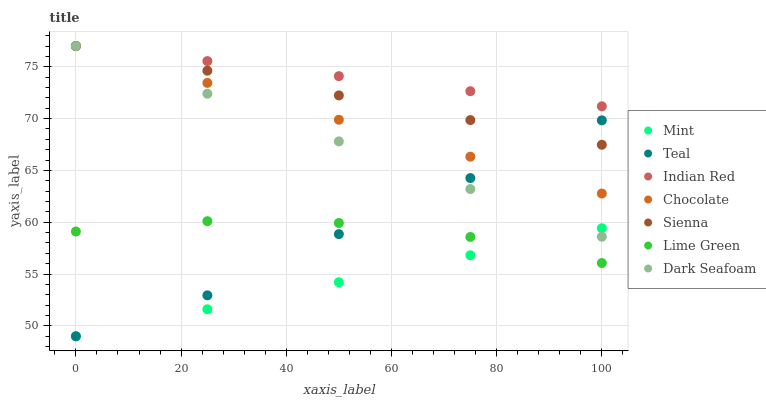Does Mint have the minimum area under the curve?
Answer yes or no. Yes. Does Indian Red have the maximum area under the curve?
Answer yes or no. Yes. Does Chocolate have the minimum area under the curve?
Answer yes or no. No. Does Chocolate have the maximum area under the curve?
Answer yes or no. No. Is Chocolate the smoothest?
Answer yes or no. Yes. Is Lime Green the roughest?
Answer yes or no. Yes. Is Mint the smoothest?
Answer yes or no. No. Is Mint the roughest?
Answer yes or no. No. Does Teal have the lowest value?
Answer yes or no. Yes. Does Chocolate have the lowest value?
Answer yes or no. No. Does Indian Red have the highest value?
Answer yes or no. Yes. Does Mint have the highest value?
Answer yes or no. No. Is Mint less than Chocolate?
Answer yes or no. Yes. Is Sienna greater than Mint?
Answer yes or no. Yes. Does Chocolate intersect Dark Seafoam?
Answer yes or no. Yes. Is Chocolate less than Dark Seafoam?
Answer yes or no. No. Is Chocolate greater than Dark Seafoam?
Answer yes or no. No. Does Mint intersect Chocolate?
Answer yes or no. No. 